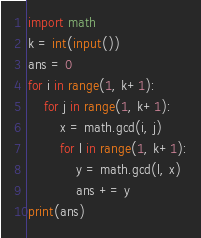<code> <loc_0><loc_0><loc_500><loc_500><_Python_>import math
k = int(input())
ans = 0
for i in range(1, k+1):
    for j in range(1, k+1):
        x = math.gcd(i, j)
        for l in range(1, k+1):
            y = math.gcd(l, x)
            ans += y
print(ans)</code> 